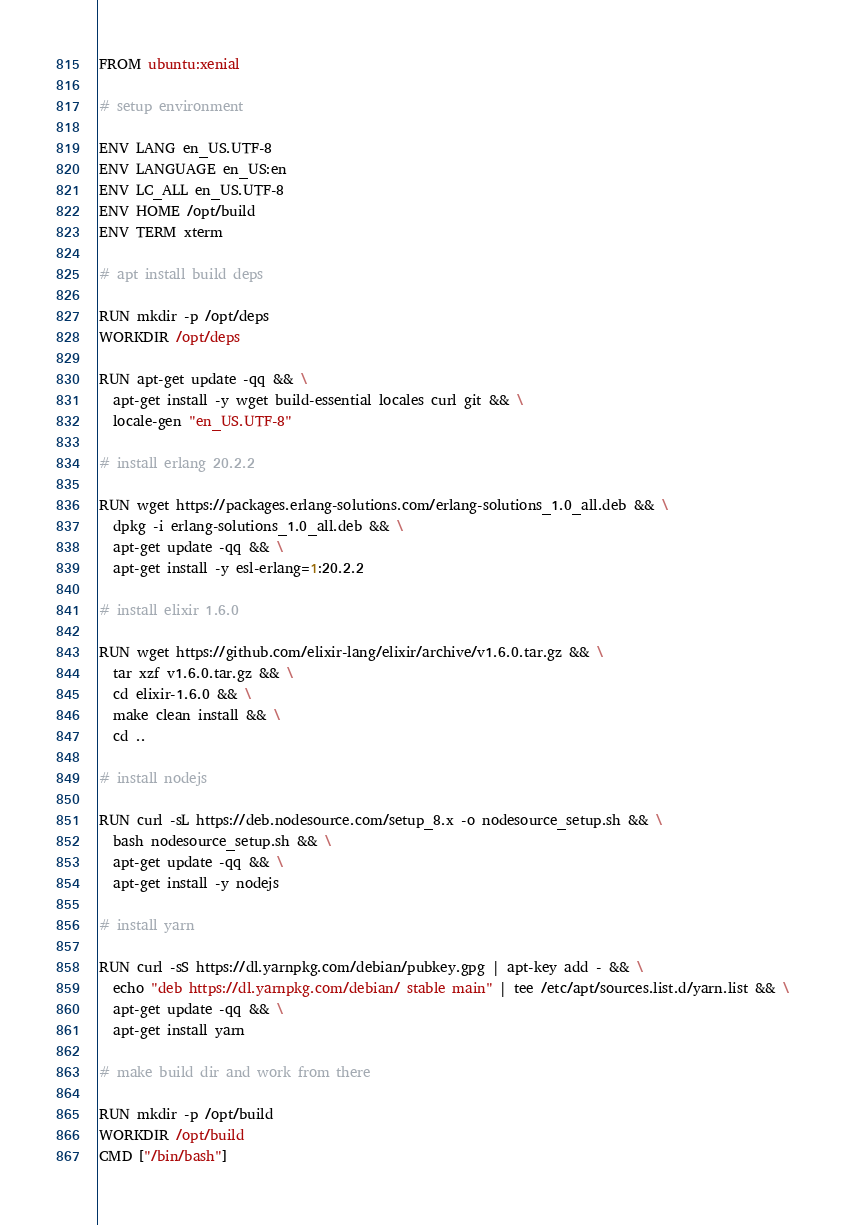Convert code to text. <code><loc_0><loc_0><loc_500><loc_500><_Dockerfile_>FROM ubuntu:xenial

# setup environment

ENV LANG en_US.UTF-8
ENV LANGUAGE en_US:en
ENV LC_ALL en_US.UTF-8
ENV HOME /opt/build
ENV TERM xterm

# apt install build deps

RUN mkdir -p /opt/deps
WORKDIR /opt/deps

RUN apt-get update -qq && \
  apt-get install -y wget build-essential locales curl git && \
  locale-gen "en_US.UTF-8"

# install erlang 20.2.2

RUN wget https://packages.erlang-solutions.com/erlang-solutions_1.0_all.deb && \
  dpkg -i erlang-solutions_1.0_all.deb && \
  apt-get update -qq && \
  apt-get install -y esl-erlang=1:20.2.2

# install elixir 1.6.0

RUN wget https://github.com/elixir-lang/elixir/archive/v1.6.0.tar.gz && \
  tar xzf v1.6.0.tar.gz && \
  cd elixir-1.6.0 && \
  make clean install && \
  cd ..

# install nodejs

RUN curl -sL https://deb.nodesource.com/setup_8.x -o nodesource_setup.sh && \
  bash nodesource_setup.sh && \
  apt-get update -qq && \
  apt-get install -y nodejs

# install yarn

RUN curl -sS https://dl.yarnpkg.com/debian/pubkey.gpg | apt-key add - && \
  echo "deb https://dl.yarnpkg.com/debian/ stable main" | tee /etc/apt/sources.list.d/yarn.list && \
  apt-get update -qq && \
  apt-get install yarn

# make build dir and work from there

RUN mkdir -p /opt/build
WORKDIR /opt/build
CMD ["/bin/bash"]
</code> 